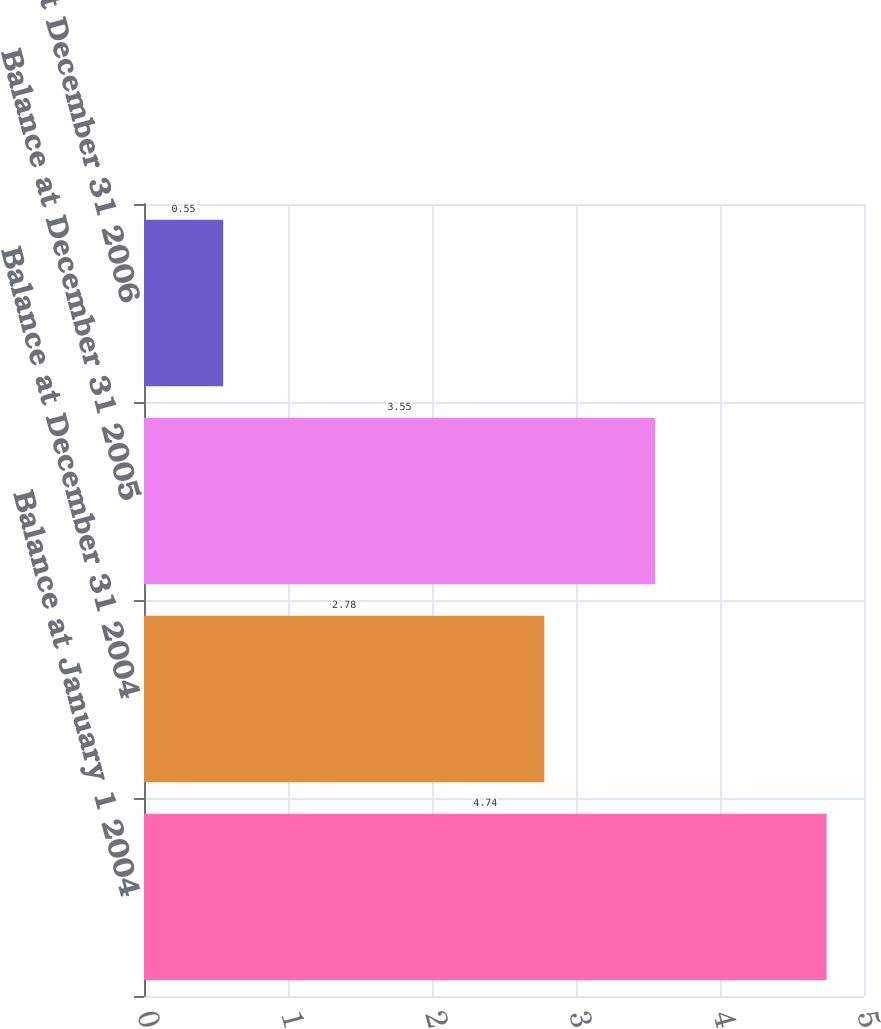<chart> <loc_0><loc_0><loc_500><loc_500><bar_chart><fcel>Balance at January 1 2004<fcel>Balance at December 31 2004<fcel>Balance at December 31 2005<fcel>Balance at December 31 2006<nl><fcel>4.74<fcel>2.78<fcel>3.55<fcel>0.55<nl></chart> 